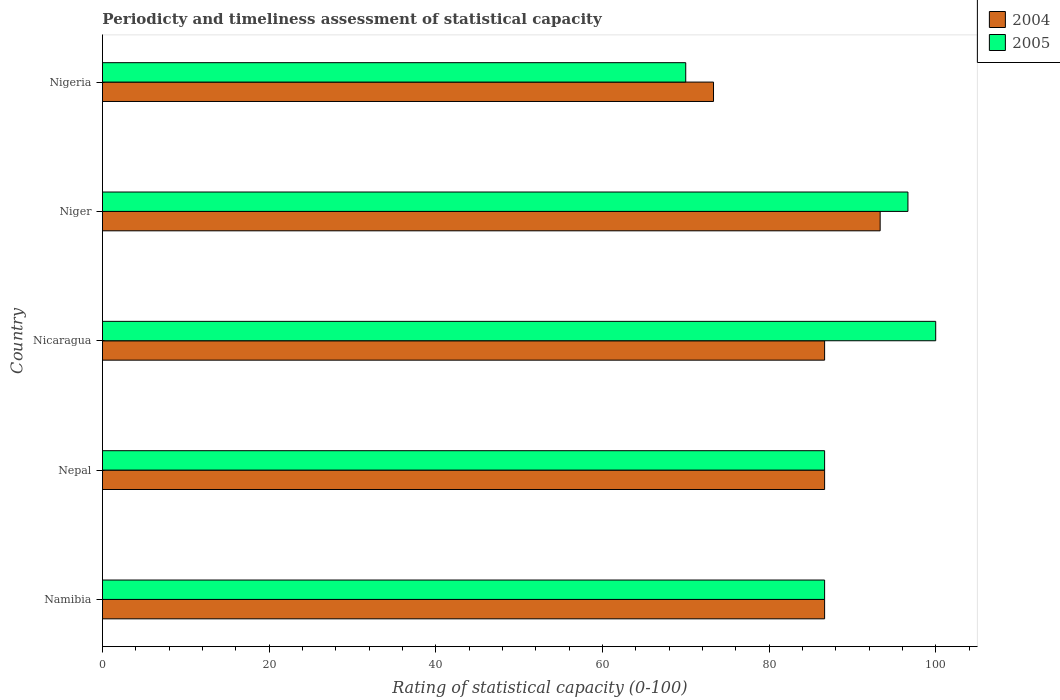How many groups of bars are there?
Provide a succinct answer. 5. Are the number of bars on each tick of the Y-axis equal?
Give a very brief answer. Yes. What is the label of the 5th group of bars from the top?
Offer a very short reply. Namibia. In how many cases, is the number of bars for a given country not equal to the number of legend labels?
Your answer should be very brief. 0. Across all countries, what is the maximum rating of statistical capacity in 2004?
Your answer should be very brief. 93.33. Across all countries, what is the minimum rating of statistical capacity in 2005?
Keep it short and to the point. 70. In which country was the rating of statistical capacity in 2004 maximum?
Offer a terse response. Niger. In which country was the rating of statistical capacity in 2004 minimum?
Your answer should be very brief. Nigeria. What is the total rating of statistical capacity in 2004 in the graph?
Offer a very short reply. 426.67. What is the difference between the rating of statistical capacity in 2005 in Nicaragua and that in Nigeria?
Provide a succinct answer. 30. What is the difference between the rating of statistical capacity in 2005 in Nicaragua and the rating of statistical capacity in 2004 in Namibia?
Ensure brevity in your answer.  13.33. What is the average rating of statistical capacity in 2005 per country?
Offer a very short reply. 88. What is the difference between the rating of statistical capacity in 2005 and rating of statistical capacity in 2004 in Nepal?
Keep it short and to the point. 0. In how many countries, is the rating of statistical capacity in 2004 greater than 52 ?
Offer a terse response. 5. What is the ratio of the rating of statistical capacity in 2005 in Namibia to that in Nepal?
Your response must be concise. 1. Is the difference between the rating of statistical capacity in 2005 in Nicaragua and Niger greater than the difference between the rating of statistical capacity in 2004 in Nicaragua and Niger?
Provide a succinct answer. Yes. What is the difference between the highest and the second highest rating of statistical capacity in 2005?
Offer a very short reply. 3.33. What is the difference between the highest and the lowest rating of statistical capacity in 2004?
Give a very brief answer. 20. In how many countries, is the rating of statistical capacity in 2004 greater than the average rating of statistical capacity in 2004 taken over all countries?
Provide a short and direct response. 4. What does the 2nd bar from the top in Nigeria represents?
Keep it short and to the point. 2004. What does the 1st bar from the bottom in Nigeria represents?
Your answer should be very brief. 2004. How many bars are there?
Ensure brevity in your answer.  10. Does the graph contain any zero values?
Make the answer very short. No. Does the graph contain grids?
Provide a short and direct response. No. How many legend labels are there?
Give a very brief answer. 2. What is the title of the graph?
Your answer should be very brief. Periodicty and timeliness assessment of statistical capacity. What is the label or title of the X-axis?
Offer a terse response. Rating of statistical capacity (0-100). What is the Rating of statistical capacity (0-100) of 2004 in Namibia?
Make the answer very short. 86.67. What is the Rating of statistical capacity (0-100) of 2005 in Namibia?
Your response must be concise. 86.67. What is the Rating of statistical capacity (0-100) of 2004 in Nepal?
Your response must be concise. 86.67. What is the Rating of statistical capacity (0-100) in 2005 in Nepal?
Offer a very short reply. 86.67. What is the Rating of statistical capacity (0-100) in 2004 in Nicaragua?
Offer a very short reply. 86.67. What is the Rating of statistical capacity (0-100) in 2005 in Nicaragua?
Ensure brevity in your answer.  100. What is the Rating of statistical capacity (0-100) of 2004 in Niger?
Your answer should be very brief. 93.33. What is the Rating of statistical capacity (0-100) in 2005 in Niger?
Your response must be concise. 96.67. What is the Rating of statistical capacity (0-100) of 2004 in Nigeria?
Your answer should be compact. 73.33. What is the Rating of statistical capacity (0-100) of 2005 in Nigeria?
Your response must be concise. 70. Across all countries, what is the maximum Rating of statistical capacity (0-100) in 2004?
Provide a short and direct response. 93.33. Across all countries, what is the maximum Rating of statistical capacity (0-100) of 2005?
Provide a succinct answer. 100. Across all countries, what is the minimum Rating of statistical capacity (0-100) of 2004?
Offer a very short reply. 73.33. What is the total Rating of statistical capacity (0-100) in 2004 in the graph?
Your answer should be compact. 426.67. What is the total Rating of statistical capacity (0-100) in 2005 in the graph?
Keep it short and to the point. 440. What is the difference between the Rating of statistical capacity (0-100) in 2005 in Namibia and that in Nepal?
Your response must be concise. 0. What is the difference between the Rating of statistical capacity (0-100) in 2004 in Namibia and that in Nicaragua?
Your answer should be compact. 0. What is the difference between the Rating of statistical capacity (0-100) of 2005 in Namibia and that in Nicaragua?
Give a very brief answer. -13.33. What is the difference between the Rating of statistical capacity (0-100) of 2004 in Namibia and that in Niger?
Keep it short and to the point. -6.67. What is the difference between the Rating of statistical capacity (0-100) of 2005 in Namibia and that in Niger?
Provide a succinct answer. -10. What is the difference between the Rating of statistical capacity (0-100) in 2004 in Namibia and that in Nigeria?
Keep it short and to the point. 13.33. What is the difference between the Rating of statistical capacity (0-100) of 2005 in Namibia and that in Nigeria?
Ensure brevity in your answer.  16.67. What is the difference between the Rating of statistical capacity (0-100) of 2004 in Nepal and that in Nicaragua?
Your response must be concise. 0. What is the difference between the Rating of statistical capacity (0-100) of 2005 in Nepal and that in Nicaragua?
Your response must be concise. -13.33. What is the difference between the Rating of statistical capacity (0-100) in 2004 in Nepal and that in Niger?
Keep it short and to the point. -6.67. What is the difference between the Rating of statistical capacity (0-100) of 2005 in Nepal and that in Niger?
Offer a terse response. -10. What is the difference between the Rating of statistical capacity (0-100) in 2004 in Nepal and that in Nigeria?
Ensure brevity in your answer.  13.33. What is the difference between the Rating of statistical capacity (0-100) of 2005 in Nepal and that in Nigeria?
Offer a terse response. 16.67. What is the difference between the Rating of statistical capacity (0-100) in 2004 in Nicaragua and that in Niger?
Make the answer very short. -6.67. What is the difference between the Rating of statistical capacity (0-100) in 2004 in Nicaragua and that in Nigeria?
Your answer should be very brief. 13.33. What is the difference between the Rating of statistical capacity (0-100) of 2005 in Nicaragua and that in Nigeria?
Give a very brief answer. 30. What is the difference between the Rating of statistical capacity (0-100) in 2004 in Niger and that in Nigeria?
Make the answer very short. 20. What is the difference between the Rating of statistical capacity (0-100) in 2005 in Niger and that in Nigeria?
Give a very brief answer. 26.67. What is the difference between the Rating of statistical capacity (0-100) in 2004 in Namibia and the Rating of statistical capacity (0-100) in 2005 in Nepal?
Provide a short and direct response. 0. What is the difference between the Rating of statistical capacity (0-100) in 2004 in Namibia and the Rating of statistical capacity (0-100) in 2005 in Nicaragua?
Your response must be concise. -13.33. What is the difference between the Rating of statistical capacity (0-100) of 2004 in Namibia and the Rating of statistical capacity (0-100) of 2005 in Nigeria?
Keep it short and to the point. 16.67. What is the difference between the Rating of statistical capacity (0-100) of 2004 in Nepal and the Rating of statistical capacity (0-100) of 2005 in Nicaragua?
Your answer should be compact. -13.33. What is the difference between the Rating of statistical capacity (0-100) in 2004 in Nepal and the Rating of statistical capacity (0-100) in 2005 in Nigeria?
Your answer should be very brief. 16.67. What is the difference between the Rating of statistical capacity (0-100) of 2004 in Nicaragua and the Rating of statistical capacity (0-100) of 2005 in Nigeria?
Make the answer very short. 16.67. What is the difference between the Rating of statistical capacity (0-100) of 2004 in Niger and the Rating of statistical capacity (0-100) of 2005 in Nigeria?
Offer a terse response. 23.33. What is the average Rating of statistical capacity (0-100) of 2004 per country?
Provide a short and direct response. 85.33. What is the average Rating of statistical capacity (0-100) of 2005 per country?
Offer a terse response. 88. What is the difference between the Rating of statistical capacity (0-100) of 2004 and Rating of statistical capacity (0-100) of 2005 in Namibia?
Provide a short and direct response. 0. What is the difference between the Rating of statistical capacity (0-100) in 2004 and Rating of statistical capacity (0-100) in 2005 in Nepal?
Ensure brevity in your answer.  0. What is the difference between the Rating of statistical capacity (0-100) of 2004 and Rating of statistical capacity (0-100) of 2005 in Nicaragua?
Provide a succinct answer. -13.33. What is the ratio of the Rating of statistical capacity (0-100) in 2004 in Namibia to that in Nepal?
Offer a very short reply. 1. What is the ratio of the Rating of statistical capacity (0-100) in 2005 in Namibia to that in Nepal?
Keep it short and to the point. 1. What is the ratio of the Rating of statistical capacity (0-100) of 2005 in Namibia to that in Nicaragua?
Keep it short and to the point. 0.87. What is the ratio of the Rating of statistical capacity (0-100) of 2004 in Namibia to that in Niger?
Provide a short and direct response. 0.93. What is the ratio of the Rating of statistical capacity (0-100) of 2005 in Namibia to that in Niger?
Make the answer very short. 0.9. What is the ratio of the Rating of statistical capacity (0-100) of 2004 in Namibia to that in Nigeria?
Your answer should be compact. 1.18. What is the ratio of the Rating of statistical capacity (0-100) of 2005 in Namibia to that in Nigeria?
Offer a very short reply. 1.24. What is the ratio of the Rating of statistical capacity (0-100) of 2004 in Nepal to that in Nicaragua?
Keep it short and to the point. 1. What is the ratio of the Rating of statistical capacity (0-100) of 2005 in Nepal to that in Nicaragua?
Offer a very short reply. 0.87. What is the ratio of the Rating of statistical capacity (0-100) of 2004 in Nepal to that in Niger?
Ensure brevity in your answer.  0.93. What is the ratio of the Rating of statistical capacity (0-100) of 2005 in Nepal to that in Niger?
Keep it short and to the point. 0.9. What is the ratio of the Rating of statistical capacity (0-100) in 2004 in Nepal to that in Nigeria?
Provide a short and direct response. 1.18. What is the ratio of the Rating of statistical capacity (0-100) of 2005 in Nepal to that in Nigeria?
Provide a short and direct response. 1.24. What is the ratio of the Rating of statistical capacity (0-100) in 2004 in Nicaragua to that in Niger?
Your answer should be very brief. 0.93. What is the ratio of the Rating of statistical capacity (0-100) of 2005 in Nicaragua to that in Niger?
Your answer should be very brief. 1.03. What is the ratio of the Rating of statistical capacity (0-100) of 2004 in Nicaragua to that in Nigeria?
Your answer should be compact. 1.18. What is the ratio of the Rating of statistical capacity (0-100) in 2005 in Nicaragua to that in Nigeria?
Make the answer very short. 1.43. What is the ratio of the Rating of statistical capacity (0-100) of 2004 in Niger to that in Nigeria?
Provide a short and direct response. 1.27. What is the ratio of the Rating of statistical capacity (0-100) of 2005 in Niger to that in Nigeria?
Ensure brevity in your answer.  1.38. What is the difference between the highest and the lowest Rating of statistical capacity (0-100) of 2004?
Your response must be concise. 20. 